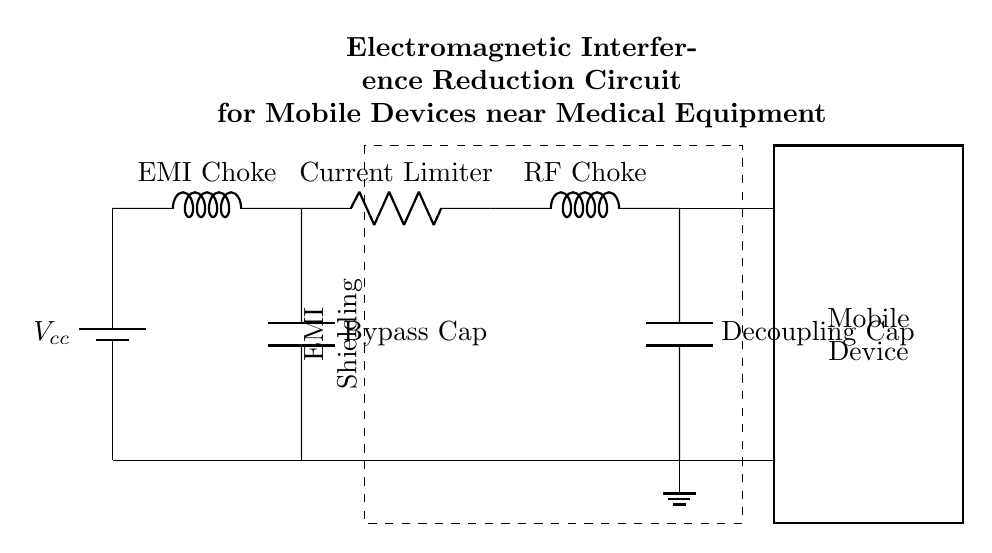What is the first component in the circuit? The first component in the circuit is a battery, labeled as Vcc, which provides the power supply to the entire circuit.
Answer: Battery What type of component is used for current limiting? The component used for current limiting is a resistor, labeled as current limiter in the circuit.
Answer: Resistor What type of capacitor is used in this circuit? The circuit features a bypass capacitor, which is typically used to filter out noise and stabilize voltage levels.
Answer: Bypass Cap How many inductors are present in the diagram? There are two inductors in the circuit: one is labeled as EMI choke and the other as RF choke.
Answer: Two What is the function of the EMI Shielding section? The EMI Shielding section is represented by a dashed rectangle, indicating that it serves to reduce electromagnetic interference from affecting the mobile device's operation, protecting sensitive medical equipment nearby.
Answer: Reduce electromagnetic interference What is connected to the ground in the circuit? The ground connection is made through a single point connected at the bottom of the circuit diagram, ensuring that all components return to a common reference point for stability and safety.
Answer: Single point ground What is the final output of the circuit meant for? The final output is directed towards the mobile device, indicating that the purpose of the circuit is to safely connect and power the mobile device while reducing EMI.
Answer: Mobile device 